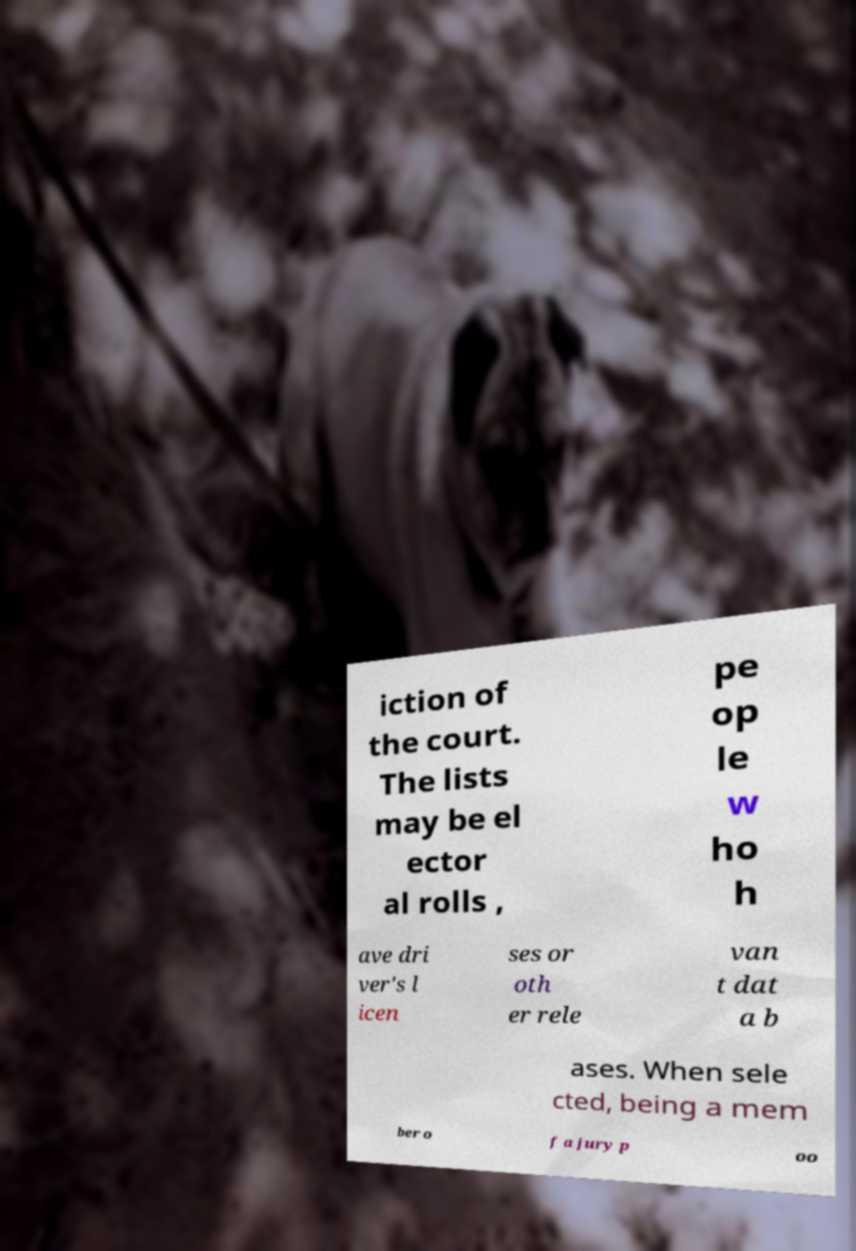Can you read and provide the text displayed in the image?This photo seems to have some interesting text. Can you extract and type it out for me? iction of the court. The lists may be el ector al rolls , pe op le w ho h ave dri ver's l icen ses or oth er rele van t dat a b ases. When sele cted, being a mem ber o f a jury p oo 